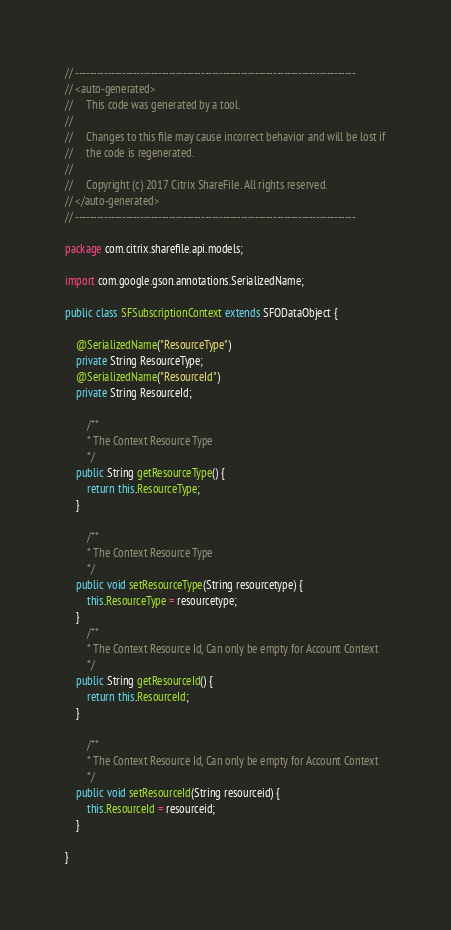<code> <loc_0><loc_0><loc_500><loc_500><_Java_>
// ------------------------------------------------------------------------------
// <auto-generated>
//     This code was generated by a tool.
//  
//     Changes to this file may cause incorrect behavior and will be lost if
//     the code is regenerated.
//     
//	   Copyright (c) 2017 Citrix ShareFile. All rights reserved.
// </auto-generated>
// ------------------------------------------------------------------------------

package com.citrix.sharefile.api.models;

import com.google.gson.annotations.SerializedName;

public class SFSubscriptionContext extends SFODataObject {

	@SerializedName("ResourceType")
	private String ResourceType;
	@SerializedName("ResourceId")
	private String ResourceId;

		/**
		* The Context Resource Type
		*/
	public String getResourceType() {
		return this.ResourceType;
	}

		/**
		* The Context Resource Type
		*/
	public void setResourceType(String resourcetype) {
		this.ResourceType = resourcetype;
	}
		/**
		* The Context Resource Id, Can only be empty for Account Context
		*/
	public String getResourceId() {
		return this.ResourceId;
	}

		/**
		* The Context Resource Id, Can only be empty for Account Context
		*/
	public void setResourceId(String resourceid) {
		this.ResourceId = resourceid;
	}

}</code> 